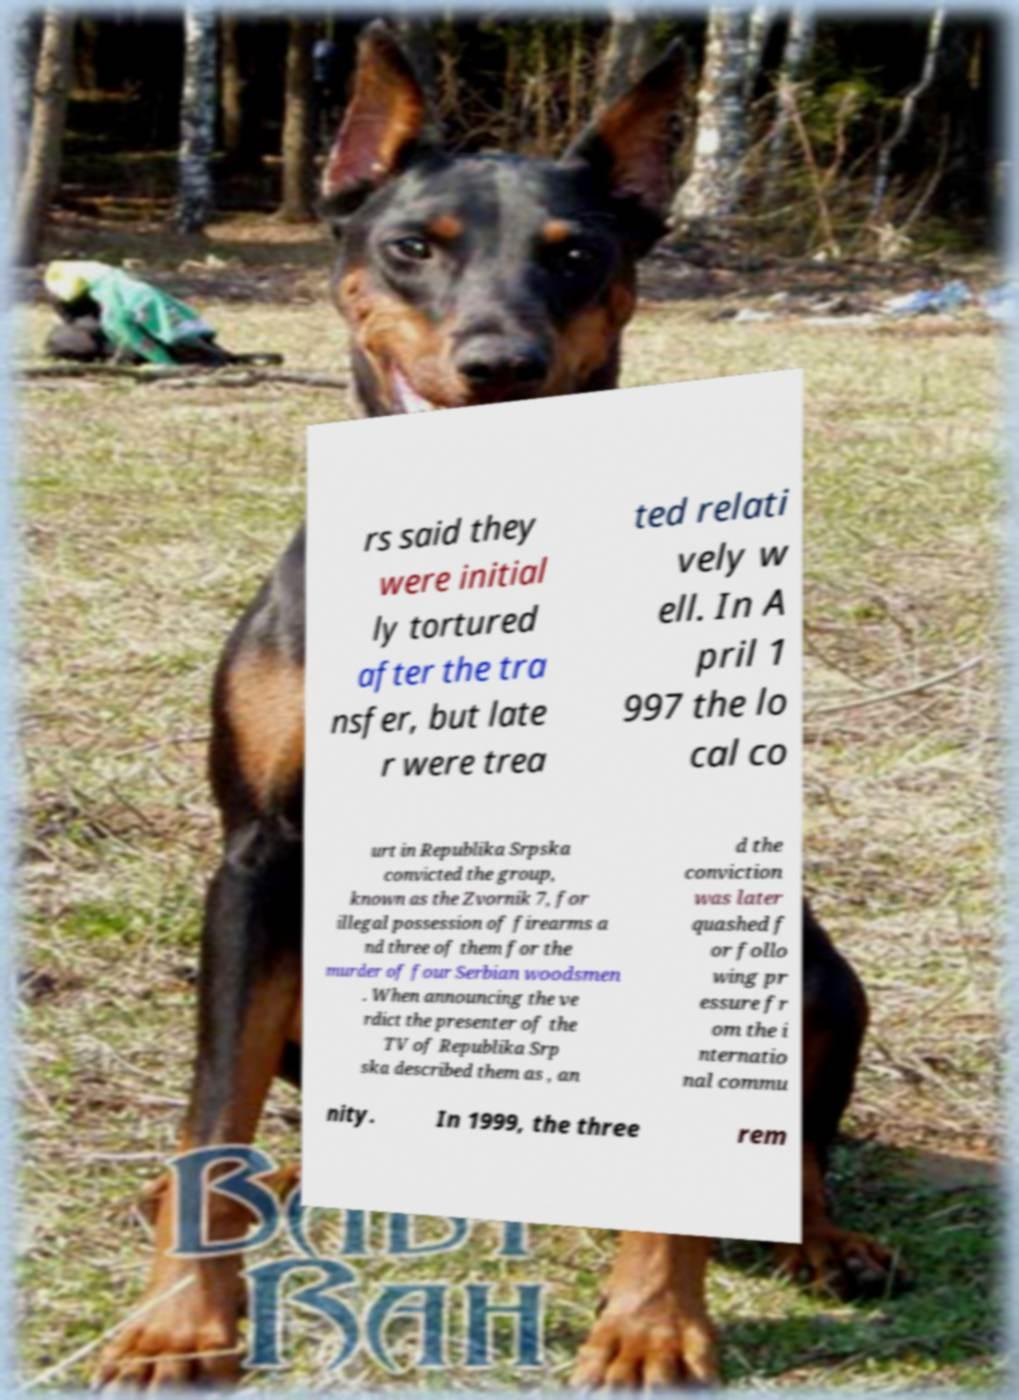For documentation purposes, I need the text within this image transcribed. Could you provide that? rs said they were initial ly tortured after the tra nsfer, but late r were trea ted relati vely w ell. In A pril 1 997 the lo cal co urt in Republika Srpska convicted the group, known as the Zvornik 7, for illegal possession of firearms a nd three of them for the murder of four Serbian woodsmen . When announcing the ve rdict the presenter of the TV of Republika Srp ska described them as , an d the conviction was later quashed f or follo wing pr essure fr om the i nternatio nal commu nity. In 1999, the three rem 